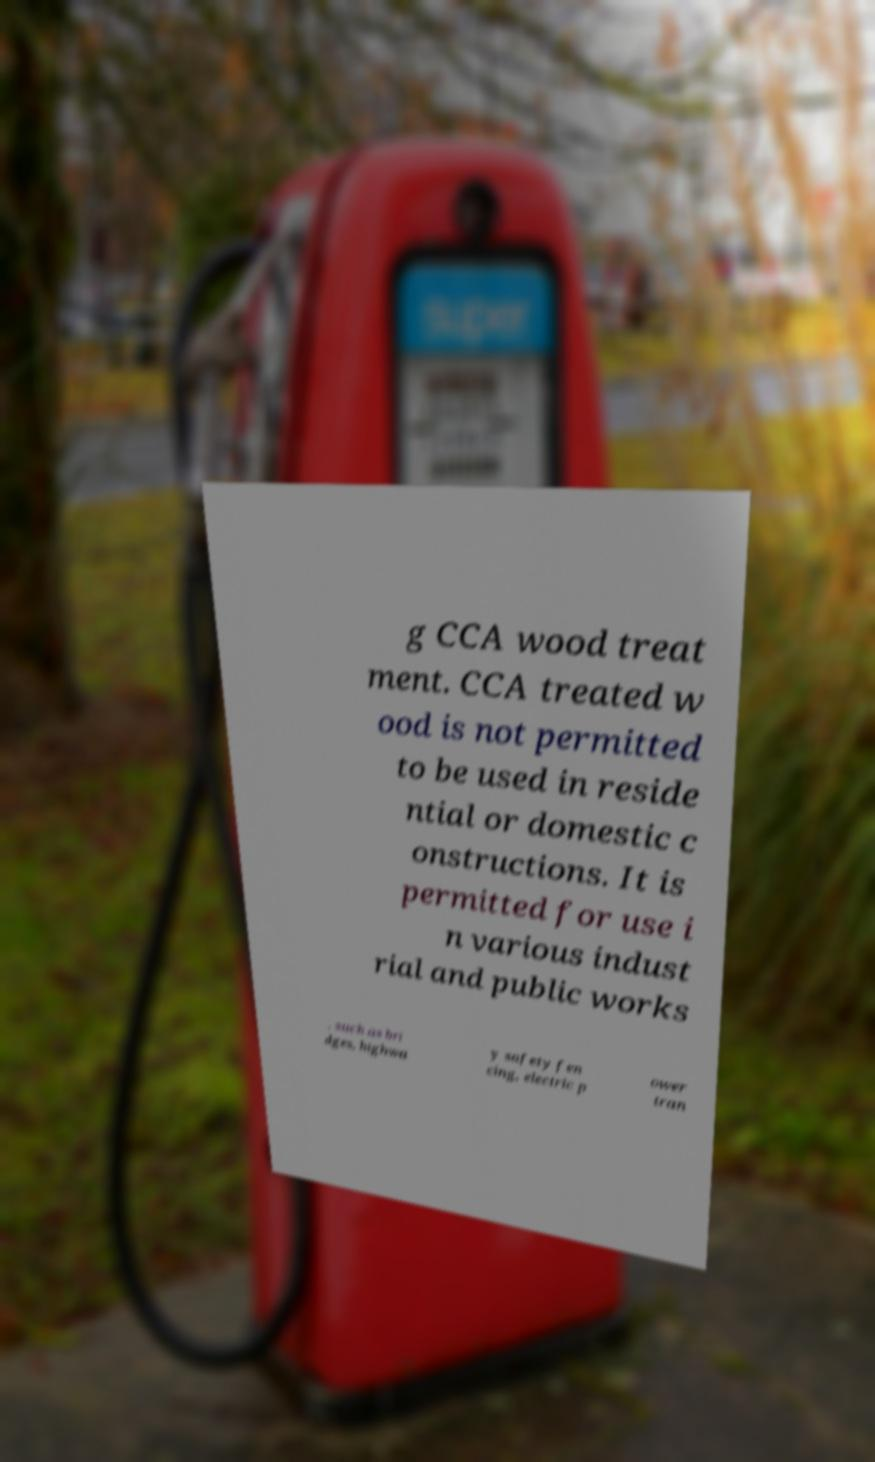There's text embedded in this image that I need extracted. Can you transcribe it verbatim? g CCA wood treat ment. CCA treated w ood is not permitted to be used in reside ntial or domestic c onstructions. It is permitted for use i n various indust rial and public works , such as bri dges, highwa y safety fen cing, electric p ower tran 